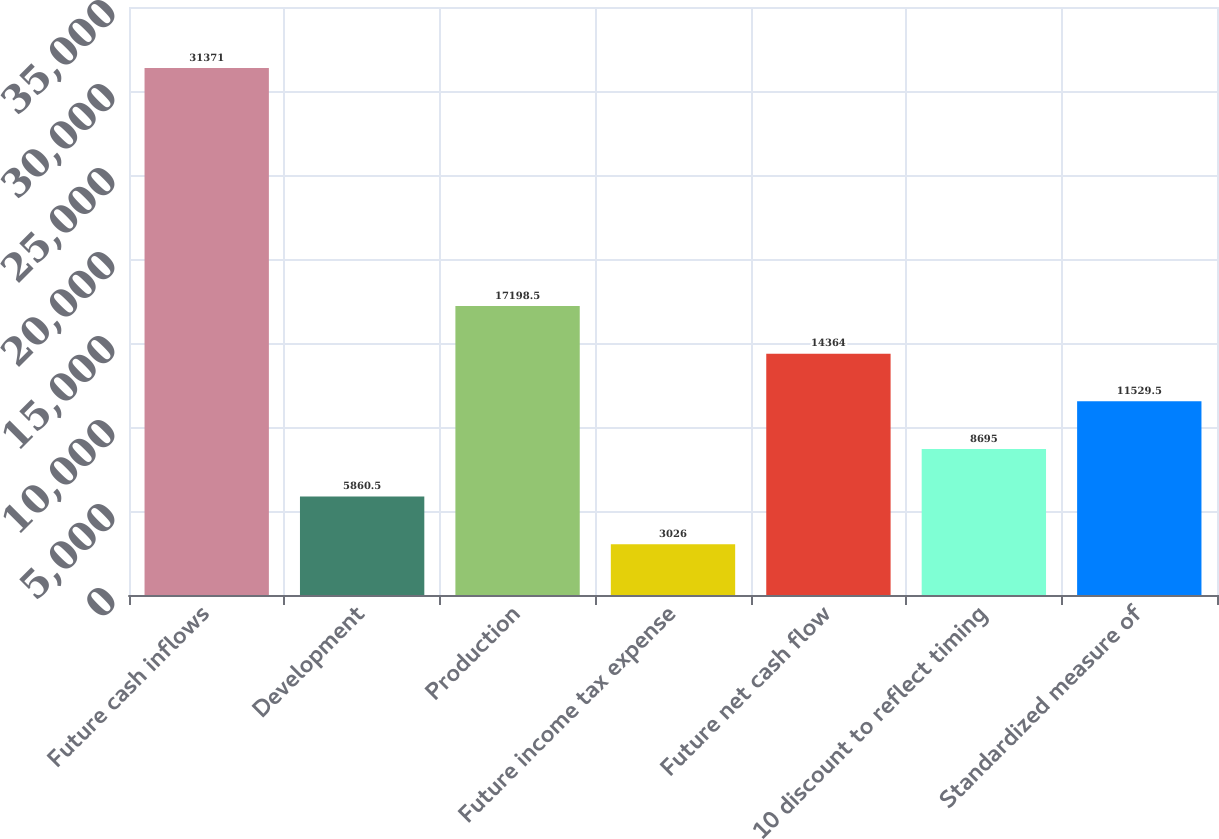<chart> <loc_0><loc_0><loc_500><loc_500><bar_chart><fcel>Future cash inflows<fcel>Development<fcel>Production<fcel>Future income tax expense<fcel>Future net cash flow<fcel>10 discount to reflect timing<fcel>Standardized measure of<nl><fcel>31371<fcel>5860.5<fcel>17198.5<fcel>3026<fcel>14364<fcel>8695<fcel>11529.5<nl></chart> 